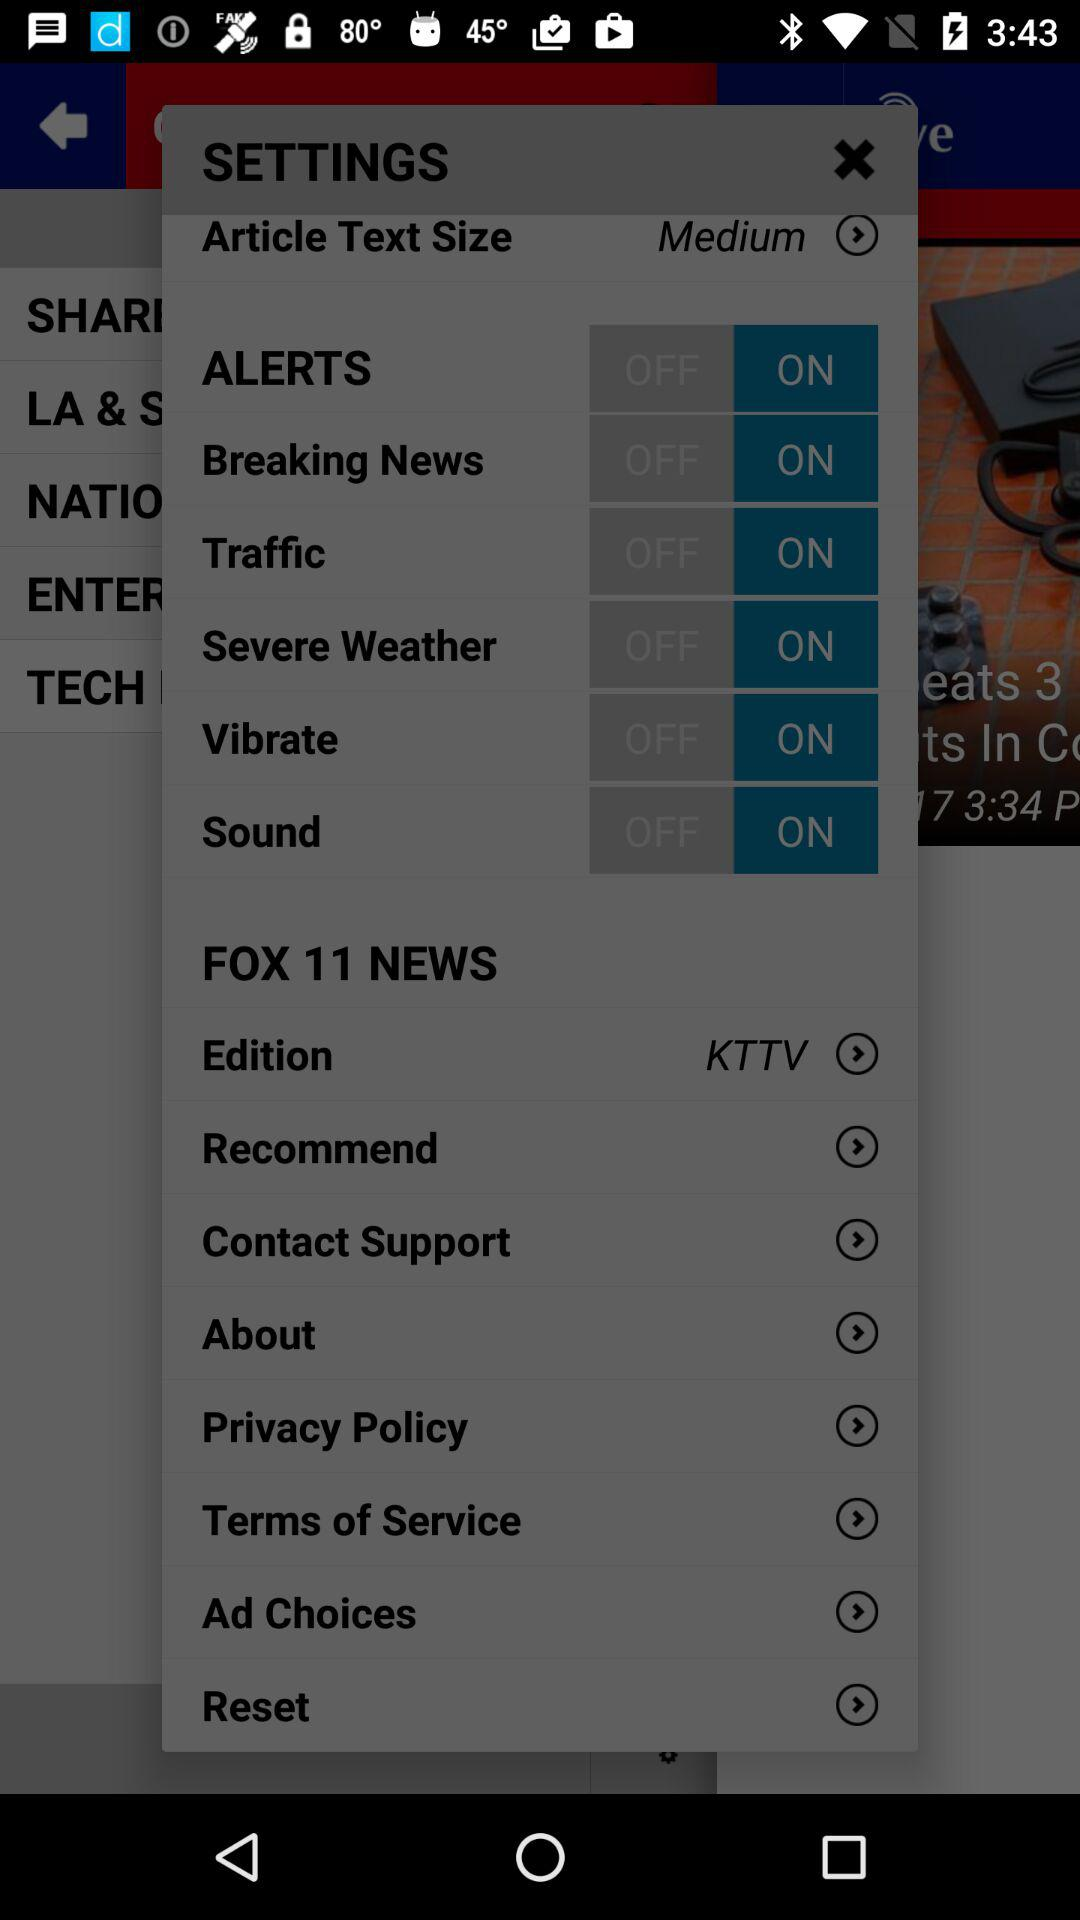What is the status of "Traffic"? The status is "on". 